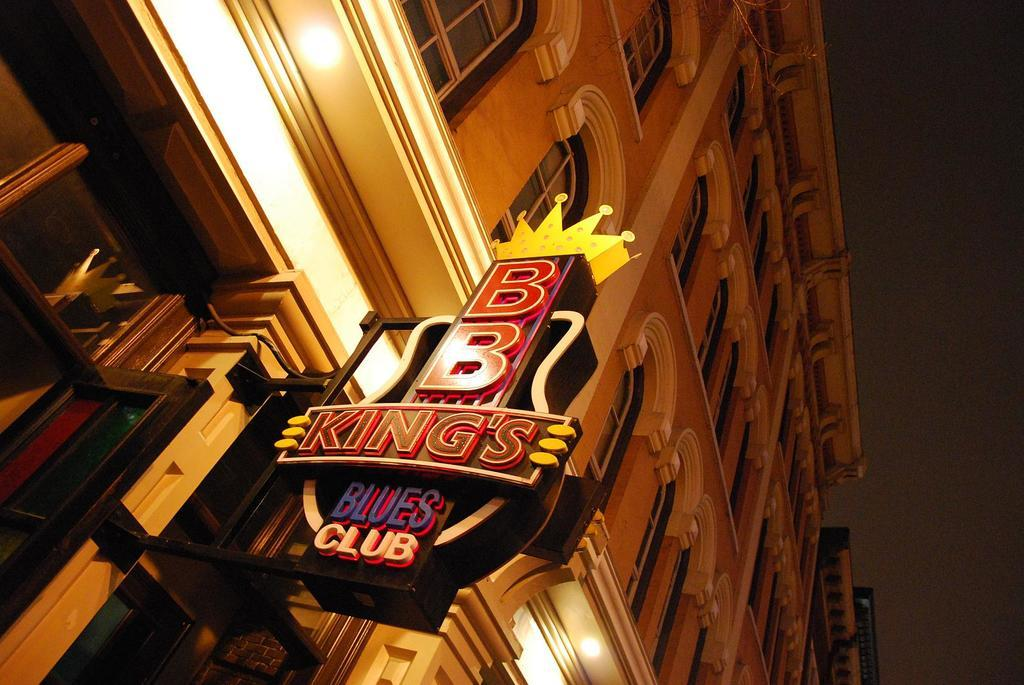What type of structure is present in the image? There is a building in the image. What feature can be seen on the building? The building has windows. What object is also visible in the image? There is a board in the image. What else can be seen in the image besides the building and board? There are lights in the image. What is visible in the background of the image? The sky is visible in the image. How does the toad contribute to the lighting in the image? There is no toad present in the image, so it cannot contribute to the lighting. 